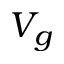<formula> <loc_0><loc_0><loc_500><loc_500>V _ { g }</formula> 